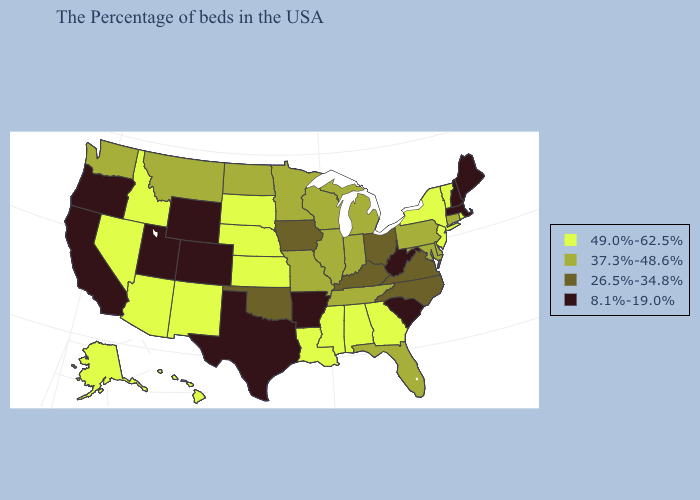What is the value of Nevada?
Give a very brief answer. 49.0%-62.5%. Which states hav the highest value in the MidWest?
Keep it brief. Kansas, Nebraska, South Dakota. Does Wyoming have the same value as Colorado?
Quick response, please. Yes. What is the lowest value in the Northeast?
Answer briefly. 8.1%-19.0%. Does Wisconsin have the highest value in the USA?
Write a very short answer. No. Does Wisconsin have the lowest value in the MidWest?
Be succinct. No. How many symbols are there in the legend?
Be succinct. 4. What is the value of Mississippi?
Short answer required. 49.0%-62.5%. Name the states that have a value in the range 26.5%-34.8%?
Write a very short answer. Virginia, North Carolina, Ohio, Kentucky, Iowa, Oklahoma. Which states have the lowest value in the USA?
Short answer required. Maine, Massachusetts, New Hampshire, South Carolina, West Virginia, Arkansas, Texas, Wyoming, Colorado, Utah, California, Oregon. What is the value of New Hampshire?
Give a very brief answer. 8.1%-19.0%. Which states hav the highest value in the West?
Short answer required. New Mexico, Arizona, Idaho, Nevada, Alaska, Hawaii. Name the states that have a value in the range 37.3%-48.6%?
Write a very short answer. Connecticut, Delaware, Maryland, Pennsylvania, Florida, Michigan, Indiana, Tennessee, Wisconsin, Illinois, Missouri, Minnesota, North Dakota, Montana, Washington. Does Tennessee have the lowest value in the South?
Keep it brief. No. Does Washington have the highest value in the USA?
Concise answer only. No. 